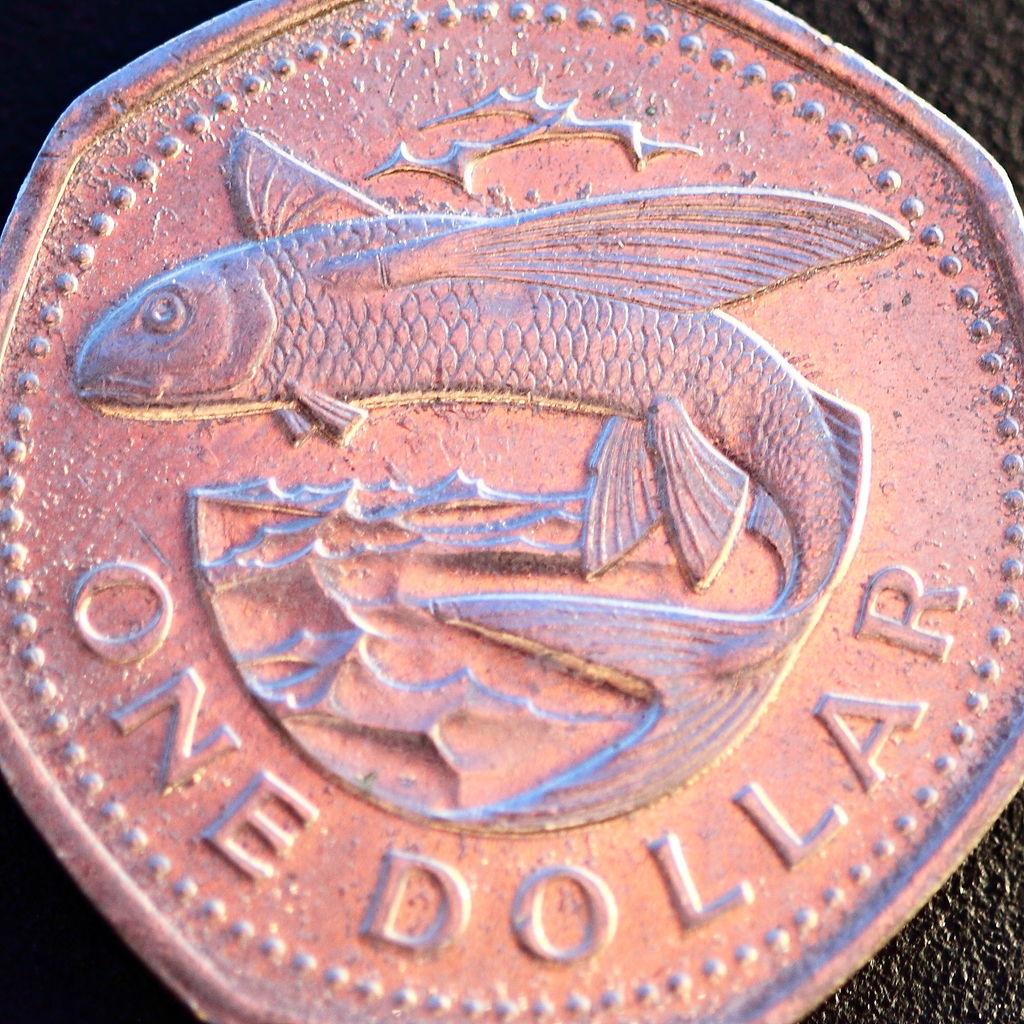One of what?
Provide a short and direct response. Dollar. How many dollars is this?
Provide a short and direct response. 1. 